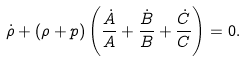Convert formula to latex. <formula><loc_0><loc_0><loc_500><loc_500>\dot { \rho } + ( \rho + p ) \left ( \frac { \dot { A } } { A } + \frac { \dot { B } } { B } + \frac { \dot { C } } { C } \right ) = 0 .</formula> 